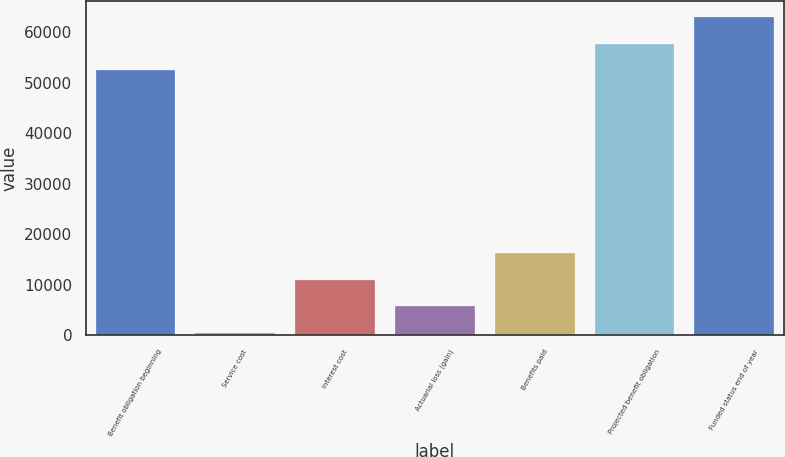<chart> <loc_0><loc_0><loc_500><loc_500><bar_chart><fcel>Benefit obligation beginning<fcel>Service cost<fcel>Interest cost<fcel>Actuarial loss (gain)<fcel>Benefits paid<fcel>Projected benefit obligation<fcel>Funded status end of year<nl><fcel>52448<fcel>424<fcel>10970<fcel>5697<fcel>16243<fcel>57721<fcel>62994<nl></chart> 